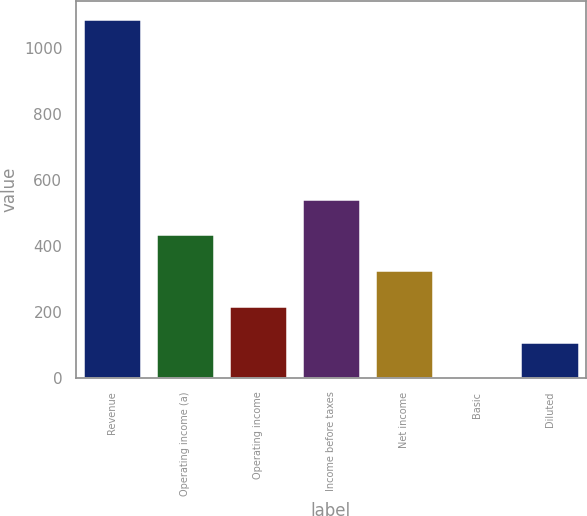Convert chart to OTSL. <chart><loc_0><loc_0><loc_500><loc_500><bar_chart><fcel>Revenue<fcel>Operating income (a)<fcel>Operating income<fcel>Income before taxes<fcel>Net income<fcel>Basic<fcel>Diluted<nl><fcel>1089.3<fcel>436.07<fcel>218.33<fcel>544.94<fcel>327.2<fcel>0.59<fcel>109.46<nl></chart> 